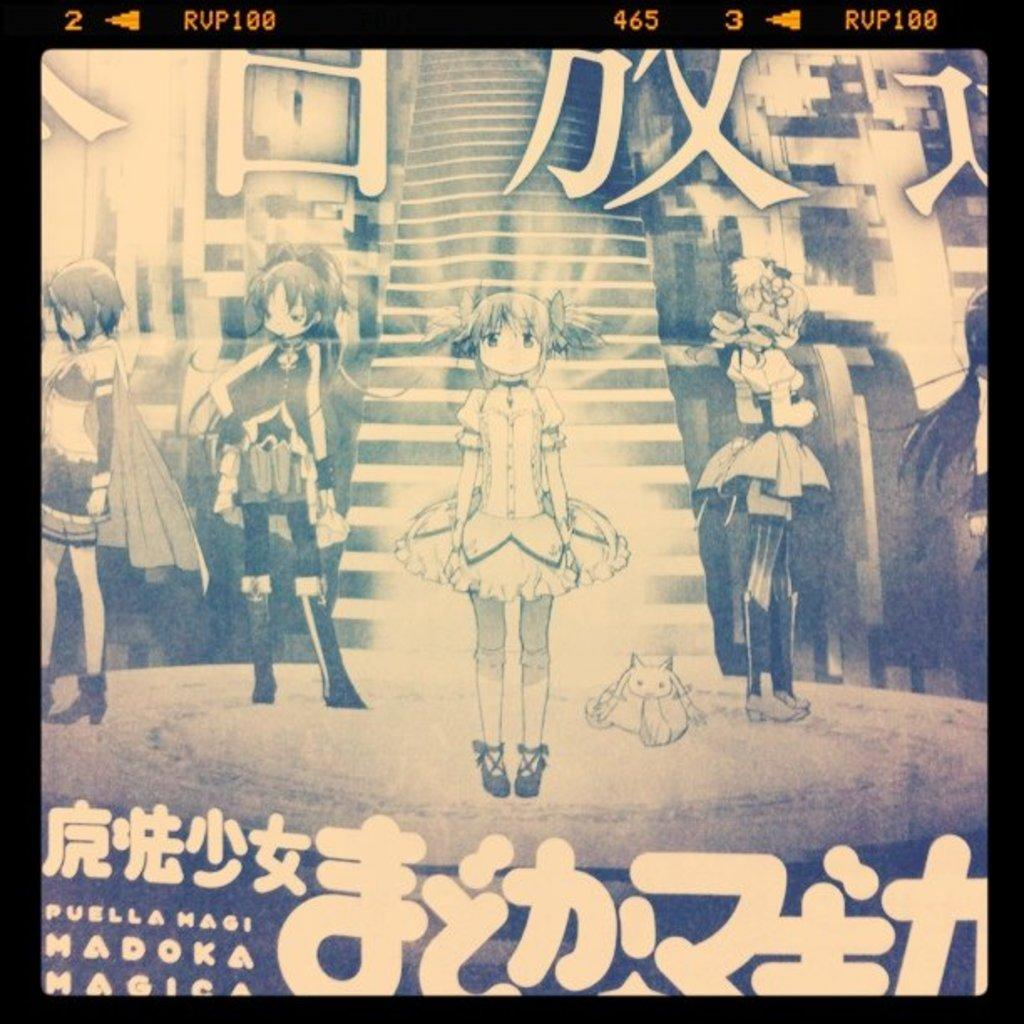What type of characters are depicted in the image? There are anime characters in the image. What are the anime characters doing in the image? The anime characters are standing in the image. What is the color scheme of the image? The image is black and white. What type of sponge can be seen in the image? There is no sponge present in the image. How does the sleet affect the anime characters in the image? There is no sleet present in the image, so it does not affect the anime characters. 